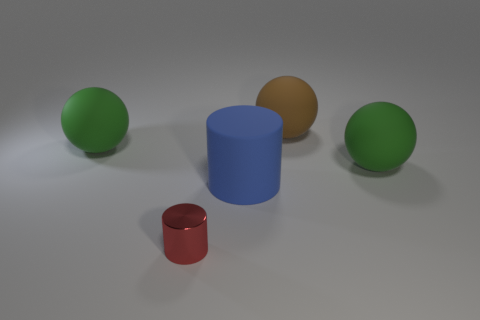The brown ball that is made of the same material as the large blue thing is what size?
Ensure brevity in your answer.  Large. What shape is the thing that is on the right side of the big blue matte cylinder and in front of the large brown object?
Your answer should be very brief. Sphere. Are there the same number of big cylinders to the left of the metal cylinder and big cylinders?
Make the answer very short. No. What number of objects are green spheres or big green rubber objects right of the brown thing?
Offer a terse response. 2. Is there another blue rubber thing of the same shape as the large blue thing?
Provide a succinct answer. No. Are there the same number of small metal cylinders that are behind the blue thing and big green objects that are behind the big brown matte object?
Your response must be concise. Yes. Are there any other things that are the same size as the shiny thing?
Offer a terse response. No. What number of purple things are either big matte balls or small things?
Provide a succinct answer. 0. What number of rubber things are the same size as the blue cylinder?
Your response must be concise. 3. The big sphere that is both in front of the brown matte object and on the right side of the large blue object is what color?
Offer a terse response. Green. 